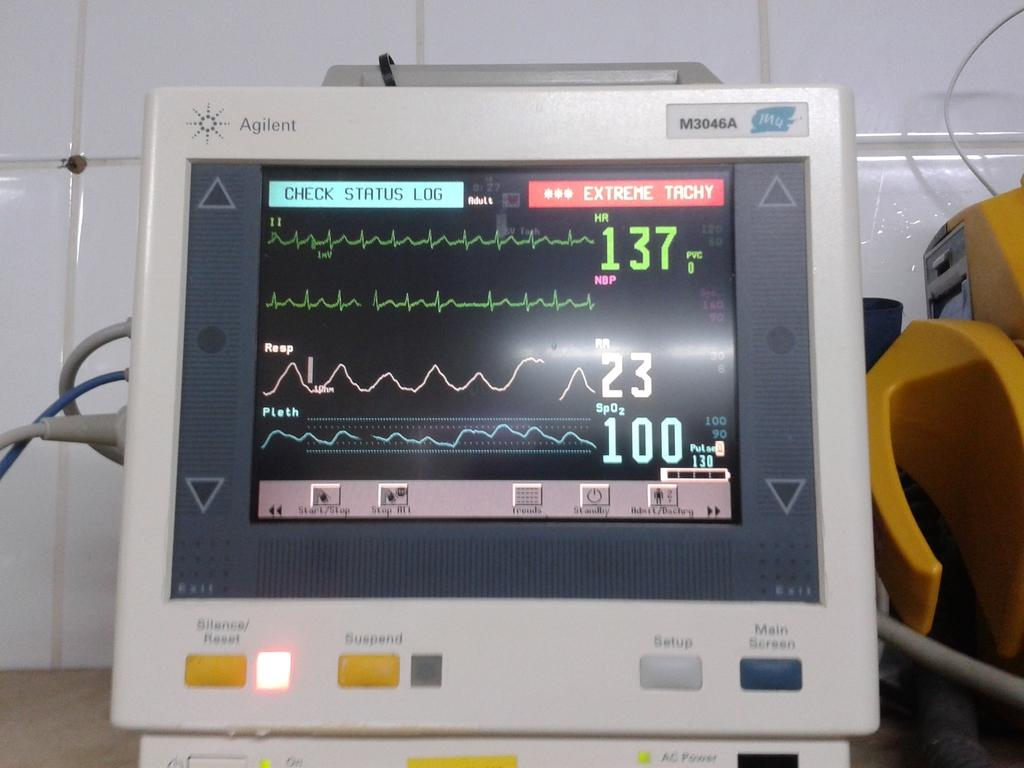What type of object can be seen in the image? A: There is an electronic device in the image. What can be seen behind the electronic device? There is a wall in the background of the image. What type of pancake is being cooked during the rainstorm in the image? There is no rainstorm or pancake present in the image; it features an electronic device and a wall in the background. 